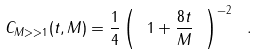Convert formula to latex. <formula><loc_0><loc_0><loc_500><loc_500>C _ { M > > 1 } ( t , M ) = \frac { 1 } { 4 } \left ( \ 1 + \frac { 8 t } { M } \ \right ) ^ { - 2 } \ .</formula> 